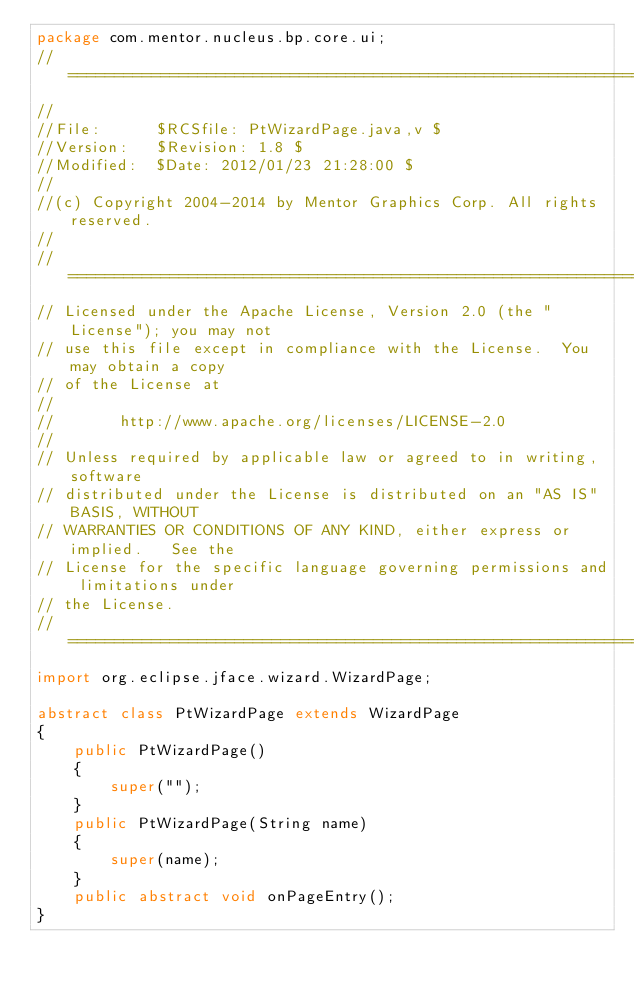Convert code to text. <code><loc_0><loc_0><loc_500><loc_500><_Java_>package com.mentor.nucleus.bp.core.ui;
//========================================================================
//
//File:      $RCSfile: PtWizardPage.java,v $
//Version:   $Revision: 1.8 $
//Modified:  $Date: 2012/01/23 21:28:00 $
//
//(c) Copyright 2004-2014 by Mentor Graphics Corp. All rights reserved.
//
//========================================================================
// Licensed under the Apache License, Version 2.0 (the "License"); you may not 
// use this file except in compliance with the License.  You may obtain a copy 
// of the License at
//
//       http://www.apache.org/licenses/LICENSE-2.0
//
// Unless required by applicable law or agreed to in writing, software 
// distributed under the License is distributed on an "AS IS" BASIS, WITHOUT 
// WARRANTIES OR CONDITIONS OF ANY KIND, either express or implied.   See the 
// License for the specific language governing permissions and limitations under
// the License.
//======================================================================== 
import org.eclipse.jface.wizard.WizardPage;

abstract class PtWizardPage extends WizardPage
{
    public PtWizardPage()
    {
        super("");
    }
    public PtWizardPage(String name)
    {
        super(name);
    }
    public abstract void onPageEntry();
}</code> 